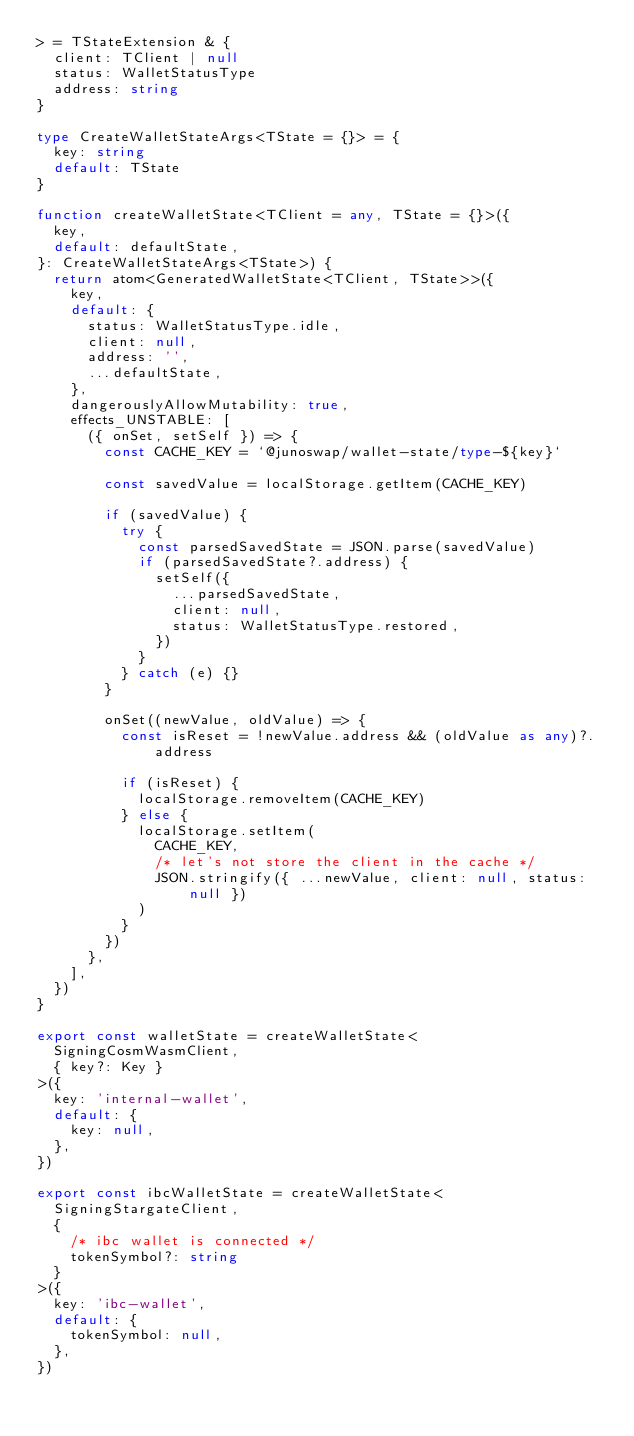Convert code to text. <code><loc_0><loc_0><loc_500><loc_500><_TypeScript_>> = TStateExtension & {
  client: TClient | null
  status: WalletStatusType
  address: string
}

type CreateWalletStateArgs<TState = {}> = {
  key: string
  default: TState
}

function createWalletState<TClient = any, TState = {}>({
  key,
  default: defaultState,
}: CreateWalletStateArgs<TState>) {
  return atom<GeneratedWalletState<TClient, TState>>({
    key,
    default: {
      status: WalletStatusType.idle,
      client: null,
      address: '',
      ...defaultState,
    },
    dangerouslyAllowMutability: true,
    effects_UNSTABLE: [
      ({ onSet, setSelf }) => {
        const CACHE_KEY = `@junoswap/wallet-state/type-${key}`

        const savedValue = localStorage.getItem(CACHE_KEY)

        if (savedValue) {
          try {
            const parsedSavedState = JSON.parse(savedValue)
            if (parsedSavedState?.address) {
              setSelf({
                ...parsedSavedState,
                client: null,
                status: WalletStatusType.restored,
              })
            }
          } catch (e) {}
        }

        onSet((newValue, oldValue) => {
          const isReset = !newValue.address && (oldValue as any)?.address

          if (isReset) {
            localStorage.removeItem(CACHE_KEY)
          } else {
            localStorage.setItem(
              CACHE_KEY,
              /* let's not store the client in the cache */
              JSON.stringify({ ...newValue, client: null, status: null })
            )
          }
        })
      },
    ],
  })
}

export const walletState = createWalletState<
  SigningCosmWasmClient,
  { key?: Key }
>({
  key: 'internal-wallet',
  default: {
    key: null,
  },
})

export const ibcWalletState = createWalletState<
  SigningStargateClient,
  {
    /* ibc wallet is connected */
    tokenSymbol?: string
  }
>({
  key: 'ibc-wallet',
  default: {
    tokenSymbol: null,
  },
})
</code> 